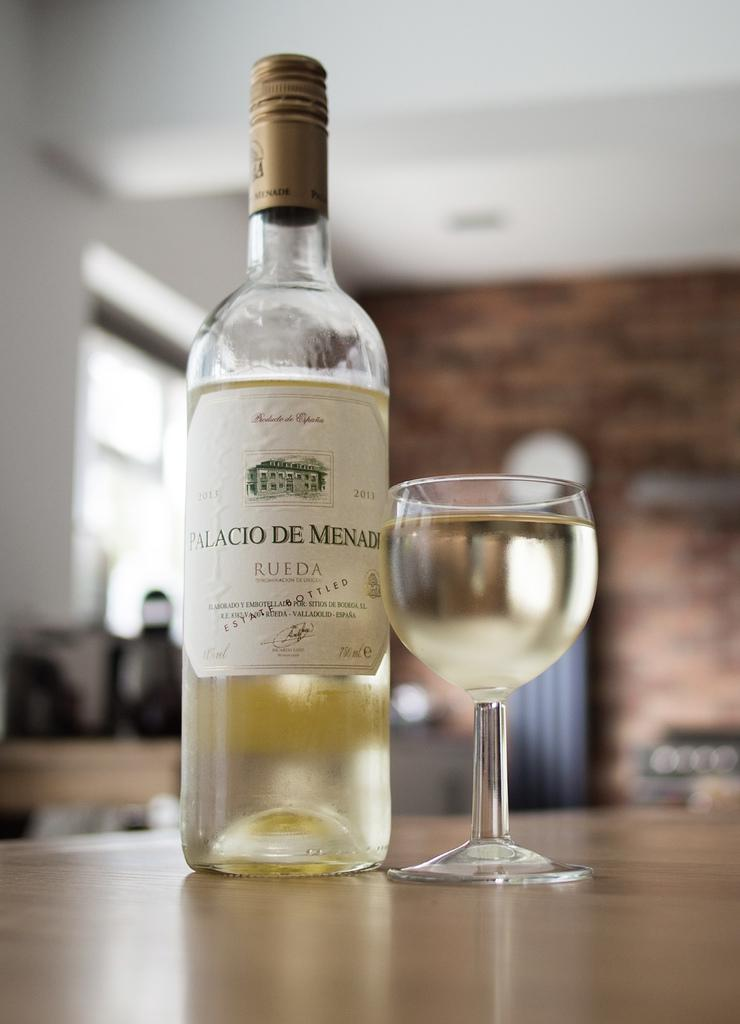What is present in the image that can hold a liquid? There is a bottle and a glass in the image. Where is the glass located in the image? The glass is on a table. What is inside the glass? There is a drink in the glass. What color is the cap of the bottle? The cap of the bottle is in golden color. Can you see any goldfish swimming in the glass in the image? No, there are no goldfish present in the image. What type of rake is being used to stir the drink in the glass? There is no rake present in the image, and the drink is not being stirred. 